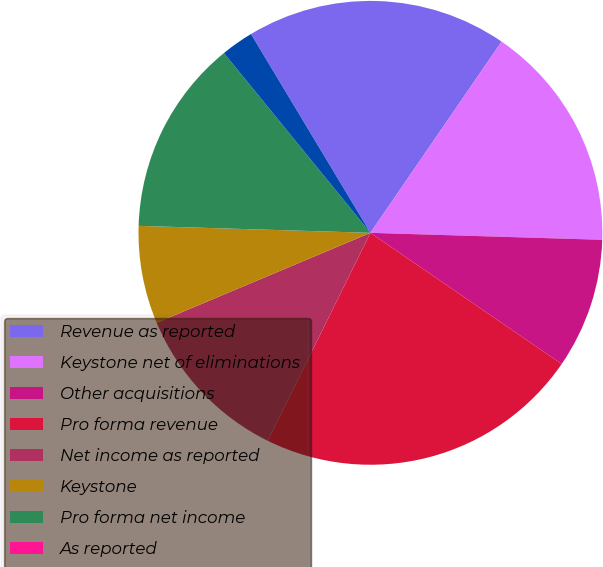<chart> <loc_0><loc_0><loc_500><loc_500><pie_chart><fcel>Revenue as reported<fcel>Keystone net of eliminations<fcel>Other acquisitions<fcel>Pro forma revenue<fcel>Net income as reported<fcel>Keystone<fcel>Pro forma net income<fcel>As reported<fcel>Pro forma earnings per<nl><fcel>18.18%<fcel>15.91%<fcel>9.09%<fcel>22.73%<fcel>11.36%<fcel>6.82%<fcel>13.64%<fcel>0.0%<fcel>2.27%<nl></chart> 